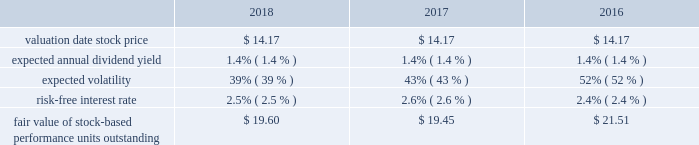Marathon oil corporation notes to consolidated financial statements stock-based performance unit awards 2013 during 2018 , 2017 and 2016 we granted 754140 , 563631 and 1205517 stock- based performance unit awards to officers .
At december 31 , 2018 , there were 1196176 units outstanding .
Total stock-based performance unit awards expense was $ 13 million in 2018 , $ 8 million in 2017 and $ 6 million in 2016 .
The key assumptions used in the monte carlo simulation to determine the fair value of stock-based performance units granted in 2018 , 2017 and 2016 were: .
18 .
Defined benefit postretirement plans and defined contribution plan we have noncontributory defined benefit pension plans covering substantially all domestic employees , as well as u.k .
Employees who were hired before april 2010 .
Certain employees located in e.g. , who are u.s .
Or u.k .
Based , also participate in these plans .
Benefits under these plans are based on plan provisions specific to each plan .
For the u.k .
Pension plan , the principal employer and plan trustees reached a decision to close the plan to future benefit accruals effective december 31 , 2015 .
We also have defined benefit plans for other postretirement benefits covering our u.s .
Employees .
Health care benefits are provided up to age 65 through comprehensive hospital , surgical and major medical benefit provisions subject to various cost- sharing features .
Post-age 65 health care benefits are provided to certain u.s .
Employees on a defined contribution basis .
Life insurance benefits are provided to certain retiree beneficiaries .
These other postretirement benefits are not funded in advance .
Employees hired after 2016 are not eligible for any postretirement health care or life insurance benefits. .
What was the average expected annual dividend yield , in percent? 
Computations: table_average(expected annual dividend yield, none)
Answer: 0.014. 